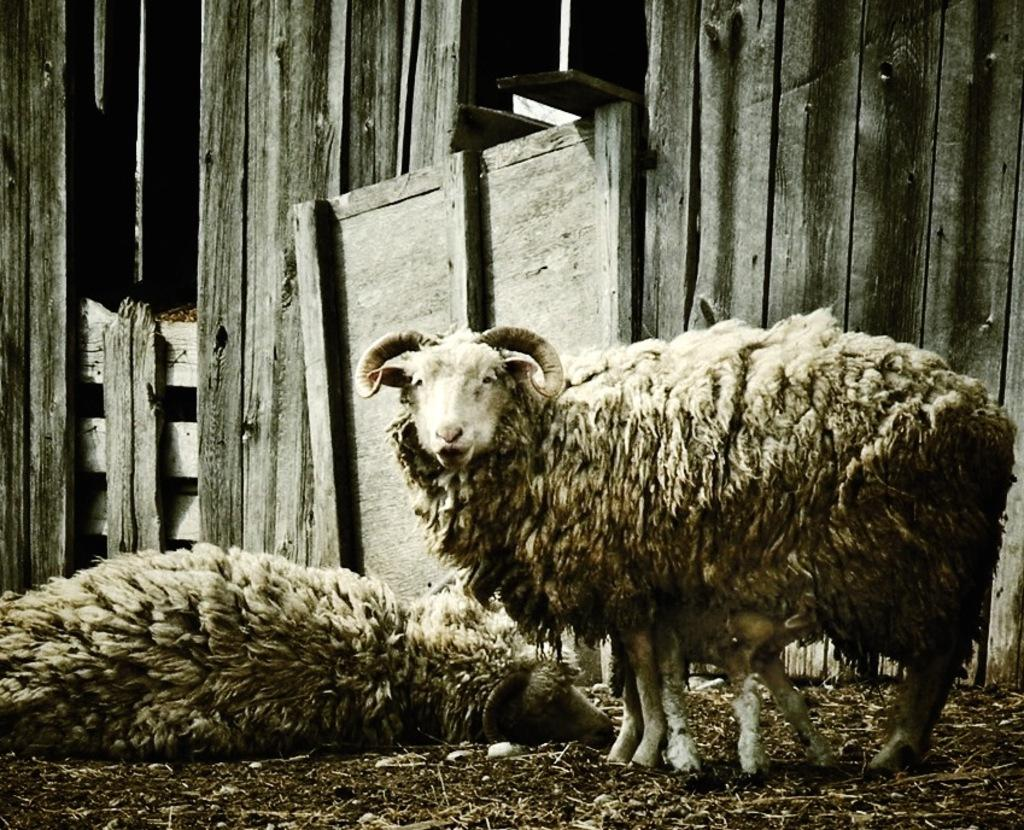What type of animals are in the image? There are sheep in the image. What can be seen in the background of the image? There is a wood wall in the background of the image. What is visible at the bottom of the image? The ground is visible at the bottom of the image. How many spades are being used by the sheep in the image? There are no spades present in the image, as it features sheep and a wood wall in the background. 